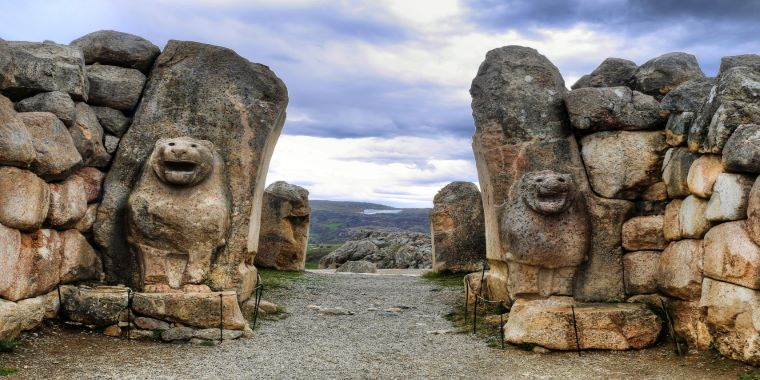Can you tell more about the significance of lions in Hittite culture? In Hittite culture, lions were emblematic symbols of strength and kingship, often associated with protection and divine authority. They frequently appeared in Hittite art and mythology, reflecting the high regard in which these animals were held. The lions at the gates of Hattusa serve not just decorative purposes, but also a spiritual and protective function, guarding the city against both physical and supernatural harm. 